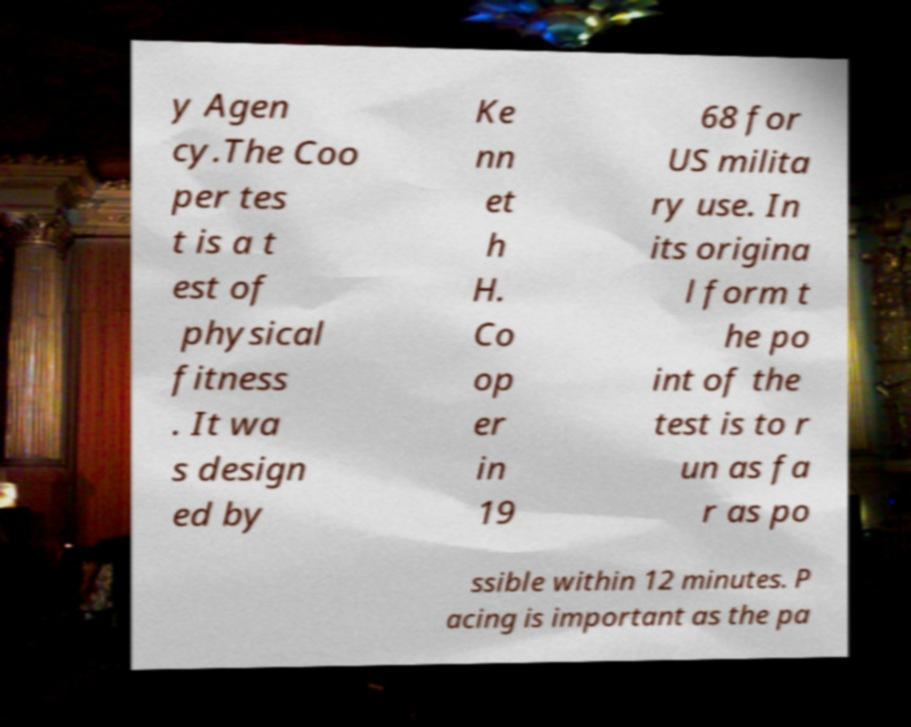There's text embedded in this image that I need extracted. Can you transcribe it verbatim? y Agen cy.The Coo per tes t is a t est of physical fitness . It wa s design ed by Ke nn et h H. Co op er in 19 68 for US milita ry use. In its origina l form t he po int of the test is to r un as fa r as po ssible within 12 minutes. P acing is important as the pa 